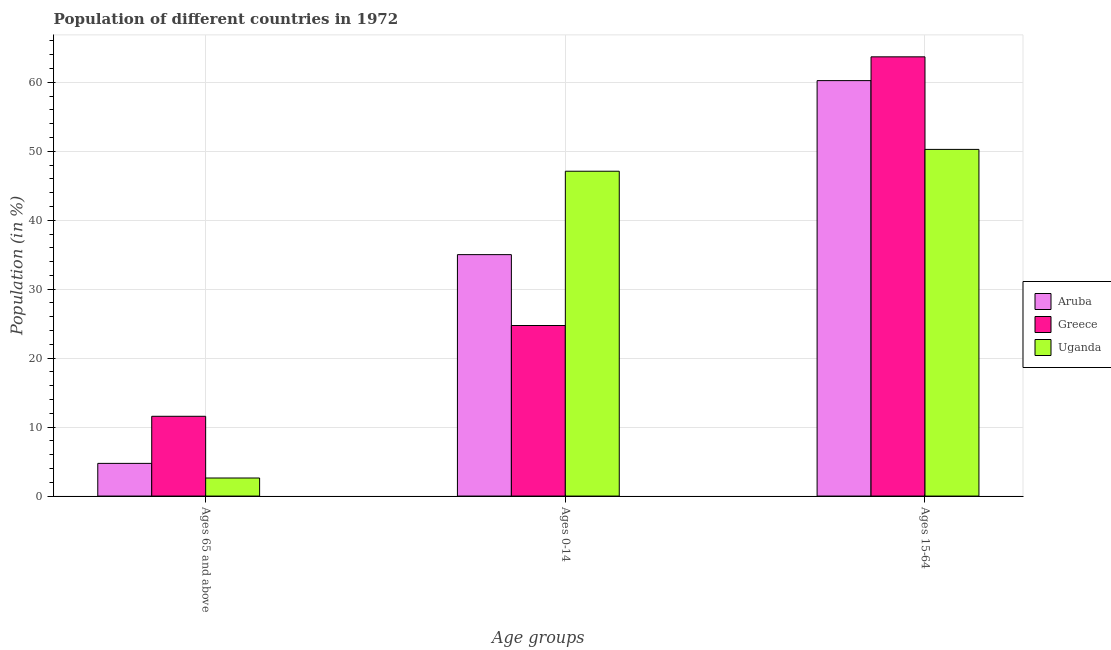How many different coloured bars are there?
Provide a succinct answer. 3. How many groups of bars are there?
Your response must be concise. 3. Are the number of bars on each tick of the X-axis equal?
Keep it short and to the point. Yes. How many bars are there on the 3rd tick from the right?
Give a very brief answer. 3. What is the label of the 2nd group of bars from the left?
Your answer should be compact. Ages 0-14. What is the percentage of population within the age-group 15-64 in Uganda?
Your response must be concise. 50.27. Across all countries, what is the maximum percentage of population within the age-group of 65 and above?
Make the answer very short. 11.57. Across all countries, what is the minimum percentage of population within the age-group 0-14?
Your answer should be very brief. 24.73. In which country was the percentage of population within the age-group 0-14 maximum?
Give a very brief answer. Uganda. What is the total percentage of population within the age-group of 65 and above in the graph?
Make the answer very short. 18.93. What is the difference between the percentage of population within the age-group 15-64 in Uganda and that in Aruba?
Provide a succinct answer. -9.98. What is the difference between the percentage of population within the age-group of 65 and above in Aruba and the percentage of population within the age-group 0-14 in Uganda?
Ensure brevity in your answer.  -42.37. What is the average percentage of population within the age-group of 65 and above per country?
Provide a succinct answer. 6.31. What is the difference between the percentage of population within the age-group 0-14 and percentage of population within the age-group of 65 and above in Aruba?
Your answer should be very brief. 30.27. What is the ratio of the percentage of population within the age-group 0-14 in Uganda to that in Greece?
Your response must be concise. 1.9. Is the percentage of population within the age-group of 65 and above in Aruba less than that in Uganda?
Ensure brevity in your answer.  No. What is the difference between the highest and the second highest percentage of population within the age-group of 65 and above?
Offer a terse response. 6.83. What is the difference between the highest and the lowest percentage of population within the age-group of 65 and above?
Your answer should be compact. 8.95. What does the 1st bar from the left in Ages 15-64 represents?
Keep it short and to the point. Aruba. What is the difference between two consecutive major ticks on the Y-axis?
Your answer should be compact. 10. Are the values on the major ticks of Y-axis written in scientific E-notation?
Offer a terse response. No. How are the legend labels stacked?
Your response must be concise. Vertical. What is the title of the graph?
Make the answer very short. Population of different countries in 1972. What is the label or title of the X-axis?
Your answer should be very brief. Age groups. What is the label or title of the Y-axis?
Offer a terse response. Population (in %). What is the Population (in %) of Aruba in Ages 65 and above?
Give a very brief answer. 4.74. What is the Population (in %) of Greece in Ages 65 and above?
Your answer should be very brief. 11.57. What is the Population (in %) of Uganda in Ages 65 and above?
Your answer should be very brief. 2.62. What is the Population (in %) of Aruba in Ages 0-14?
Ensure brevity in your answer.  35.01. What is the Population (in %) of Greece in Ages 0-14?
Provide a succinct answer. 24.73. What is the Population (in %) in Uganda in Ages 0-14?
Your response must be concise. 47.11. What is the Population (in %) in Aruba in Ages 15-64?
Your answer should be very brief. 60.25. What is the Population (in %) in Greece in Ages 15-64?
Your answer should be compact. 63.7. What is the Population (in %) of Uganda in Ages 15-64?
Your answer should be very brief. 50.27. Across all Age groups, what is the maximum Population (in %) in Aruba?
Give a very brief answer. 60.25. Across all Age groups, what is the maximum Population (in %) of Greece?
Make the answer very short. 63.7. Across all Age groups, what is the maximum Population (in %) in Uganda?
Provide a succinct answer. 50.27. Across all Age groups, what is the minimum Population (in %) in Aruba?
Give a very brief answer. 4.74. Across all Age groups, what is the minimum Population (in %) in Greece?
Offer a terse response. 11.57. Across all Age groups, what is the minimum Population (in %) of Uganda?
Provide a short and direct response. 2.62. What is the total Population (in %) in Aruba in the graph?
Offer a very short reply. 100. What is the total Population (in %) of Greece in the graph?
Give a very brief answer. 100. What is the total Population (in %) in Uganda in the graph?
Offer a very short reply. 100. What is the difference between the Population (in %) of Aruba in Ages 65 and above and that in Ages 0-14?
Provide a short and direct response. -30.27. What is the difference between the Population (in %) in Greece in Ages 65 and above and that in Ages 0-14?
Ensure brevity in your answer.  -13.16. What is the difference between the Population (in %) in Uganda in Ages 65 and above and that in Ages 0-14?
Your response must be concise. -44.49. What is the difference between the Population (in %) of Aruba in Ages 65 and above and that in Ages 15-64?
Give a very brief answer. -55.51. What is the difference between the Population (in %) in Greece in Ages 65 and above and that in Ages 15-64?
Offer a terse response. -52.13. What is the difference between the Population (in %) of Uganda in Ages 65 and above and that in Ages 15-64?
Keep it short and to the point. -47.65. What is the difference between the Population (in %) of Aruba in Ages 0-14 and that in Ages 15-64?
Offer a very short reply. -25.24. What is the difference between the Population (in %) of Greece in Ages 0-14 and that in Ages 15-64?
Your answer should be compact. -38.96. What is the difference between the Population (in %) of Uganda in Ages 0-14 and that in Ages 15-64?
Your response must be concise. -3.16. What is the difference between the Population (in %) in Aruba in Ages 65 and above and the Population (in %) in Greece in Ages 0-14?
Provide a short and direct response. -19.99. What is the difference between the Population (in %) of Aruba in Ages 65 and above and the Population (in %) of Uganda in Ages 0-14?
Provide a short and direct response. -42.37. What is the difference between the Population (in %) of Greece in Ages 65 and above and the Population (in %) of Uganda in Ages 0-14?
Keep it short and to the point. -35.54. What is the difference between the Population (in %) of Aruba in Ages 65 and above and the Population (in %) of Greece in Ages 15-64?
Your answer should be compact. -58.96. What is the difference between the Population (in %) in Aruba in Ages 65 and above and the Population (in %) in Uganda in Ages 15-64?
Your response must be concise. -45.53. What is the difference between the Population (in %) in Greece in Ages 65 and above and the Population (in %) in Uganda in Ages 15-64?
Your answer should be very brief. -38.7. What is the difference between the Population (in %) in Aruba in Ages 0-14 and the Population (in %) in Greece in Ages 15-64?
Offer a very short reply. -28.68. What is the difference between the Population (in %) in Aruba in Ages 0-14 and the Population (in %) in Uganda in Ages 15-64?
Your response must be concise. -15.26. What is the difference between the Population (in %) in Greece in Ages 0-14 and the Population (in %) in Uganda in Ages 15-64?
Your answer should be compact. -25.54. What is the average Population (in %) of Aruba per Age groups?
Keep it short and to the point. 33.33. What is the average Population (in %) in Greece per Age groups?
Provide a short and direct response. 33.33. What is the average Population (in %) of Uganda per Age groups?
Your answer should be compact. 33.33. What is the difference between the Population (in %) in Aruba and Population (in %) in Greece in Ages 65 and above?
Offer a very short reply. -6.83. What is the difference between the Population (in %) of Aruba and Population (in %) of Uganda in Ages 65 and above?
Give a very brief answer. 2.12. What is the difference between the Population (in %) in Greece and Population (in %) in Uganda in Ages 65 and above?
Provide a short and direct response. 8.95. What is the difference between the Population (in %) of Aruba and Population (in %) of Greece in Ages 0-14?
Give a very brief answer. 10.28. What is the difference between the Population (in %) in Aruba and Population (in %) in Uganda in Ages 0-14?
Offer a very short reply. -12.1. What is the difference between the Population (in %) in Greece and Population (in %) in Uganda in Ages 0-14?
Provide a succinct answer. -22.37. What is the difference between the Population (in %) in Aruba and Population (in %) in Greece in Ages 15-64?
Offer a terse response. -3.45. What is the difference between the Population (in %) in Aruba and Population (in %) in Uganda in Ages 15-64?
Ensure brevity in your answer.  9.98. What is the difference between the Population (in %) of Greece and Population (in %) of Uganda in Ages 15-64?
Give a very brief answer. 13.42. What is the ratio of the Population (in %) in Aruba in Ages 65 and above to that in Ages 0-14?
Your answer should be compact. 0.14. What is the ratio of the Population (in %) in Greece in Ages 65 and above to that in Ages 0-14?
Your answer should be very brief. 0.47. What is the ratio of the Population (in %) of Uganda in Ages 65 and above to that in Ages 0-14?
Your response must be concise. 0.06. What is the ratio of the Population (in %) of Aruba in Ages 65 and above to that in Ages 15-64?
Provide a short and direct response. 0.08. What is the ratio of the Population (in %) in Greece in Ages 65 and above to that in Ages 15-64?
Offer a terse response. 0.18. What is the ratio of the Population (in %) in Uganda in Ages 65 and above to that in Ages 15-64?
Ensure brevity in your answer.  0.05. What is the ratio of the Population (in %) of Aruba in Ages 0-14 to that in Ages 15-64?
Offer a terse response. 0.58. What is the ratio of the Population (in %) of Greece in Ages 0-14 to that in Ages 15-64?
Your response must be concise. 0.39. What is the ratio of the Population (in %) of Uganda in Ages 0-14 to that in Ages 15-64?
Your answer should be very brief. 0.94. What is the difference between the highest and the second highest Population (in %) in Aruba?
Provide a short and direct response. 25.24. What is the difference between the highest and the second highest Population (in %) in Greece?
Your response must be concise. 38.96. What is the difference between the highest and the second highest Population (in %) in Uganda?
Provide a succinct answer. 3.16. What is the difference between the highest and the lowest Population (in %) of Aruba?
Give a very brief answer. 55.51. What is the difference between the highest and the lowest Population (in %) in Greece?
Make the answer very short. 52.13. What is the difference between the highest and the lowest Population (in %) of Uganda?
Your answer should be compact. 47.65. 